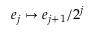Convert formula to latex. <formula><loc_0><loc_0><loc_500><loc_500>e _ { j } \mapsto e _ { j + 1 } / 2 ^ { j }</formula> 